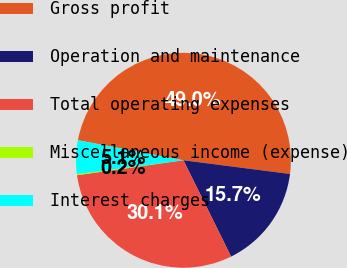Convert chart to OTSL. <chart><loc_0><loc_0><loc_500><loc_500><pie_chart><fcel>Gross profit<fcel>Operation and maintenance<fcel>Total operating expenses<fcel>Miscellaneous income (expense)<fcel>Interest charges<nl><fcel>49.04%<fcel>15.65%<fcel>30.09%<fcel>0.16%<fcel>5.05%<nl></chart> 